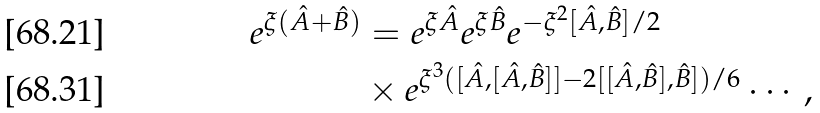<formula> <loc_0><loc_0><loc_500><loc_500>e ^ { \xi ( \hat { A } + \hat { B } ) } & = e ^ { \xi \hat { A } } e ^ { \xi \hat { B } } e ^ { - \xi ^ { 2 } [ \hat { A } , \hat { B } ] / 2 } \\ & \times e ^ { \xi ^ { 3 } ( [ \hat { A } , [ \hat { A } , \hat { B } ] ] - 2 [ [ \hat { A } , \hat { B } ] , \hat { B } ] ) / 6 } \cdots ,</formula> 